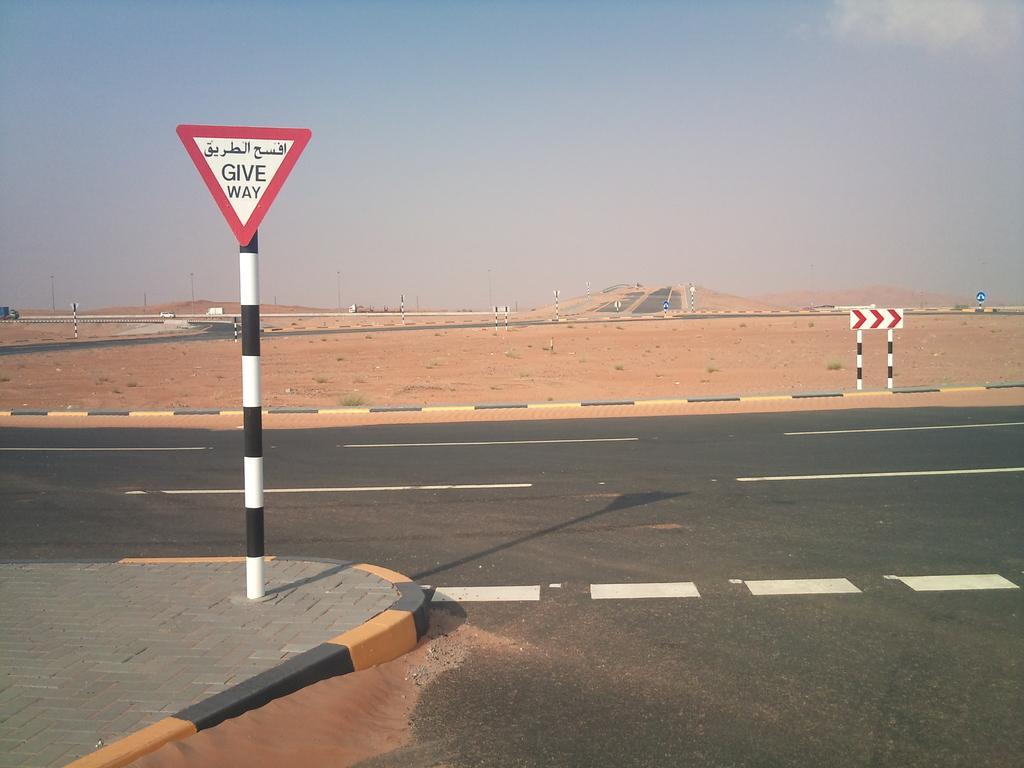Could you give a brief overview of what you see in this image? In the image there is a road and on the left side there is a caution board on the footpath, behind the road there is a sand surface. 